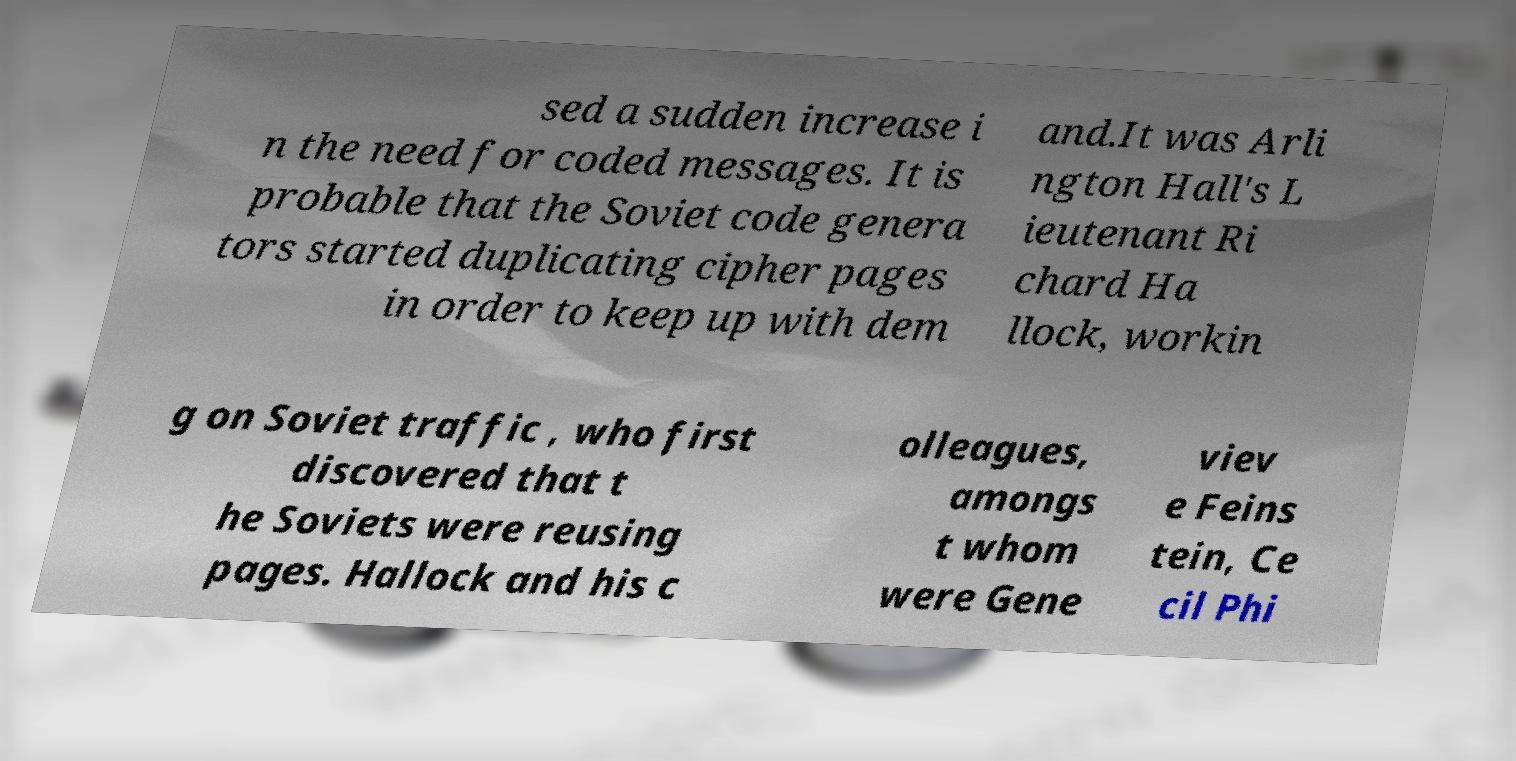Please identify and transcribe the text found in this image. sed a sudden increase i n the need for coded messages. It is probable that the Soviet code genera tors started duplicating cipher pages in order to keep up with dem and.It was Arli ngton Hall's L ieutenant Ri chard Ha llock, workin g on Soviet traffic , who first discovered that t he Soviets were reusing pages. Hallock and his c olleagues, amongs t whom were Gene viev e Feins tein, Ce cil Phi 